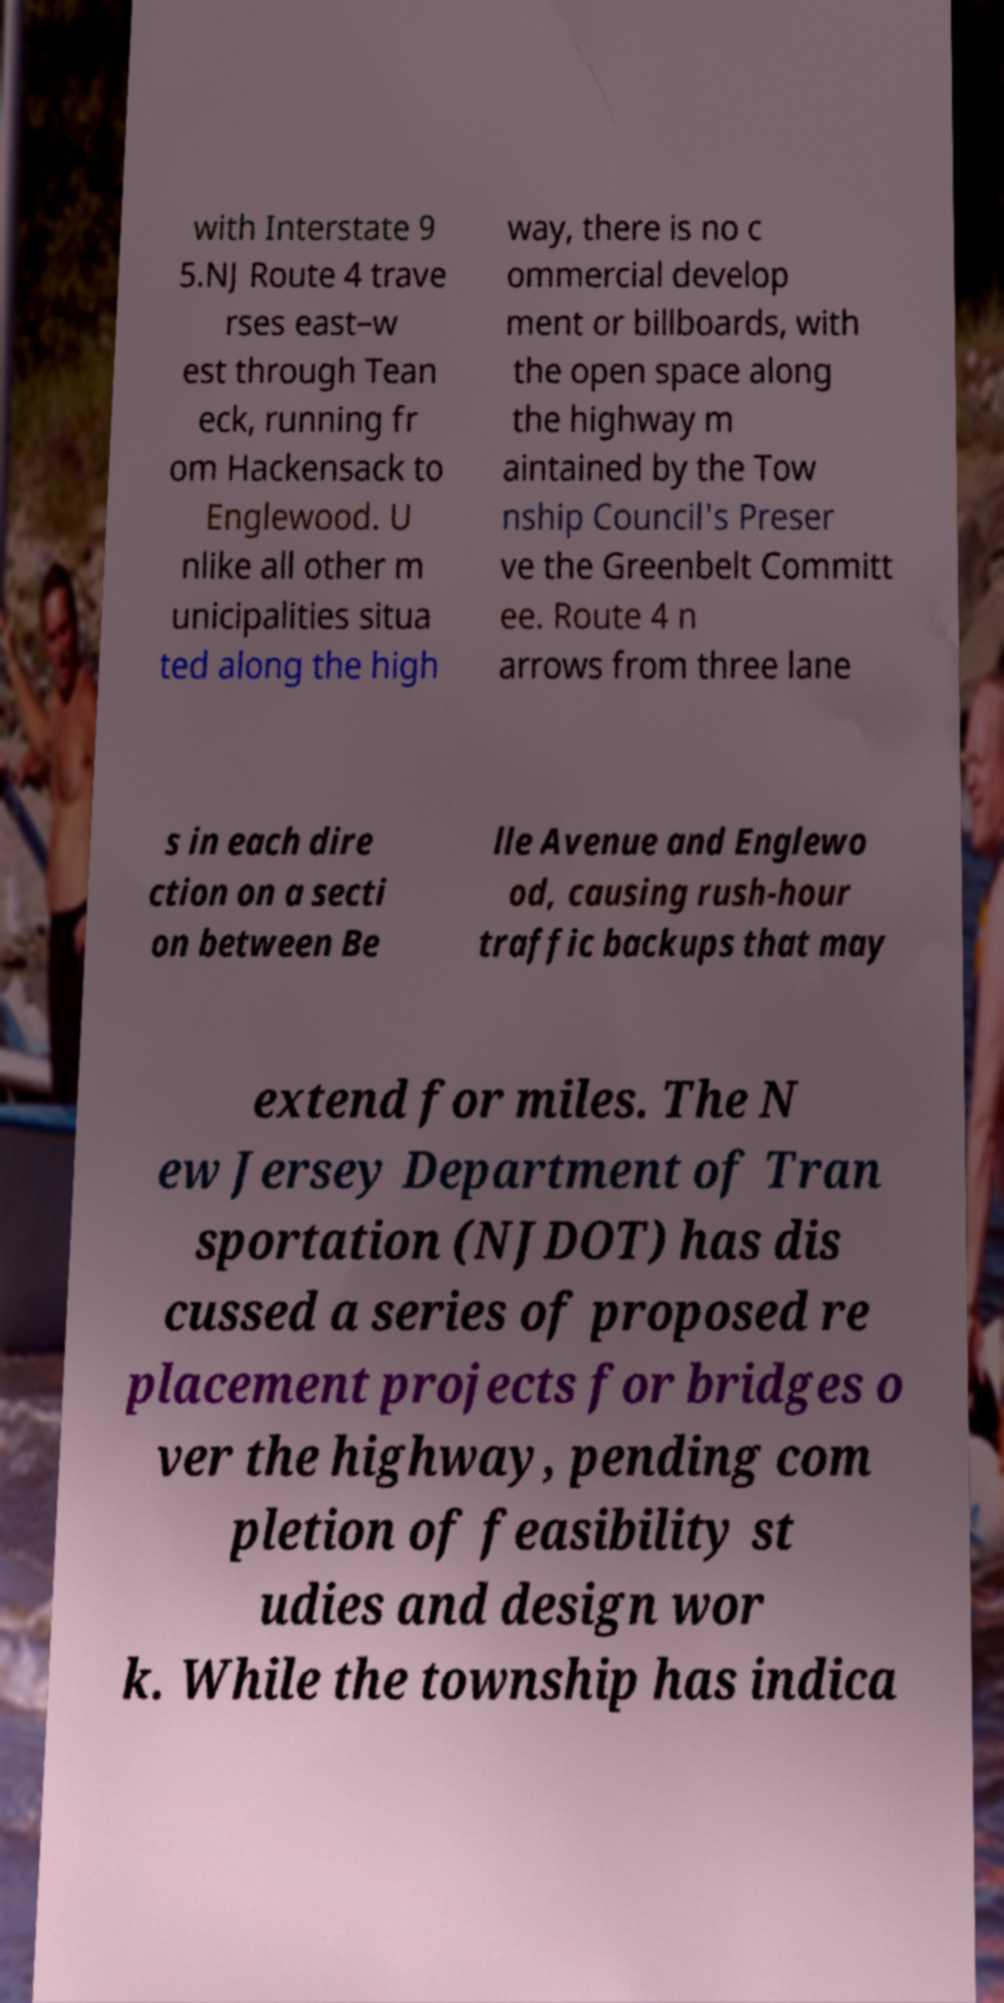There's text embedded in this image that I need extracted. Can you transcribe it verbatim? with Interstate 9 5.NJ Route 4 trave rses east–w est through Tean eck, running fr om Hackensack to Englewood. U nlike all other m unicipalities situa ted along the high way, there is no c ommercial develop ment or billboards, with the open space along the highway m aintained by the Tow nship Council's Preser ve the Greenbelt Committ ee. Route 4 n arrows from three lane s in each dire ction on a secti on between Be lle Avenue and Englewo od, causing rush-hour traffic backups that may extend for miles. The N ew Jersey Department of Tran sportation (NJDOT) has dis cussed a series of proposed re placement projects for bridges o ver the highway, pending com pletion of feasibility st udies and design wor k. While the township has indica 